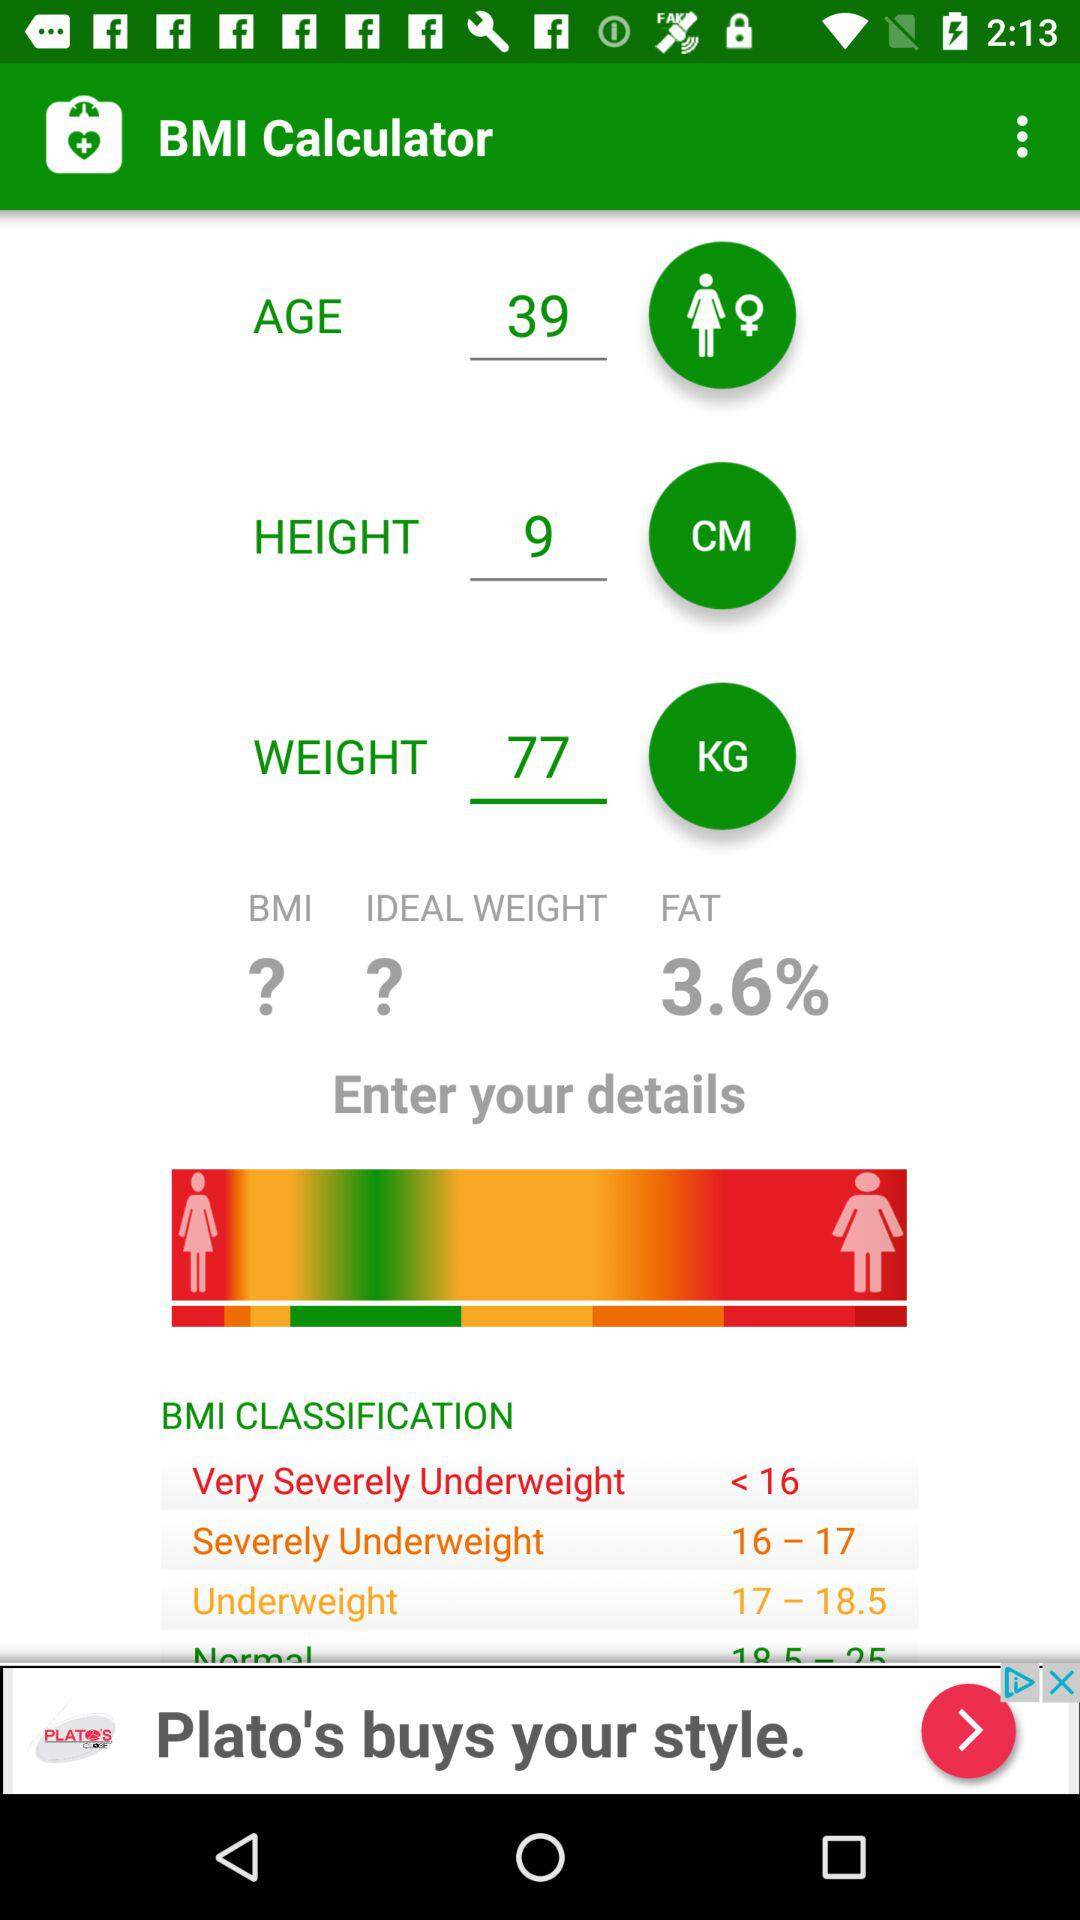What is the BMI classification for someone with a BMI of 25?
Answer the question using a single word or phrase. Normal 